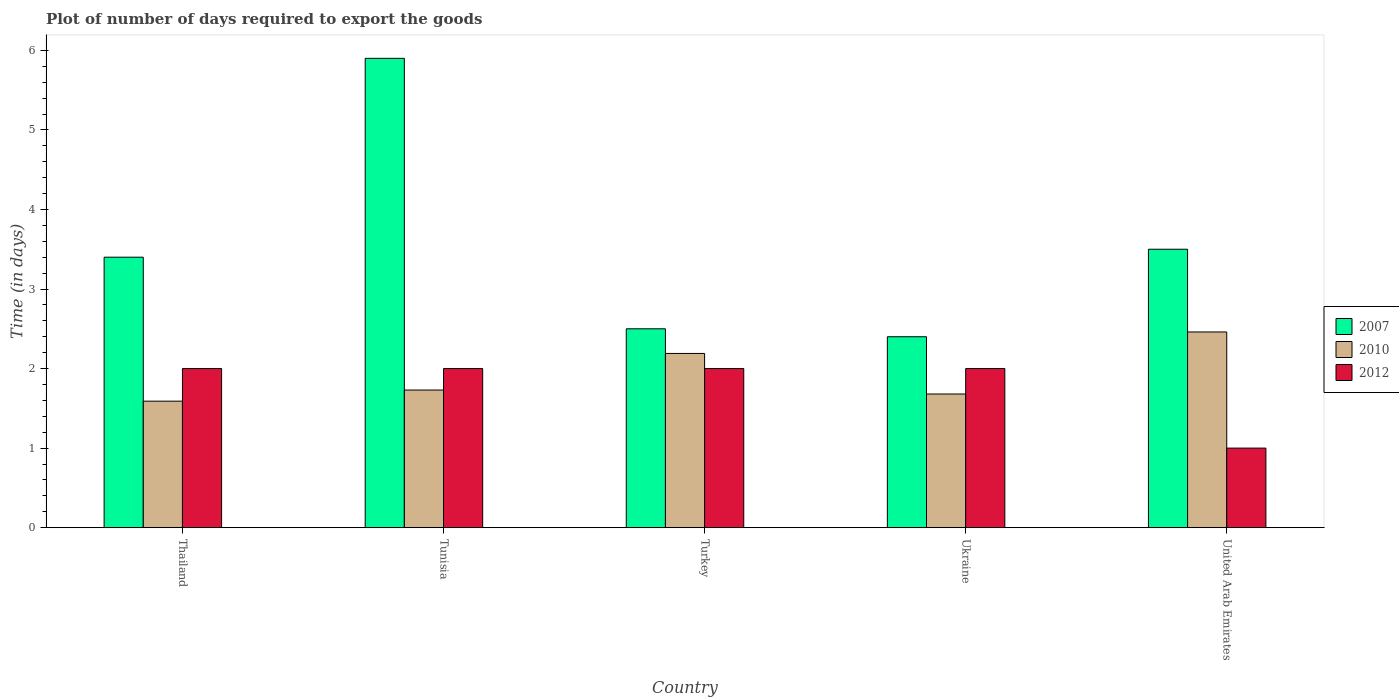What is the label of the 1st group of bars from the left?
Keep it short and to the point. Thailand. In how many cases, is the number of bars for a given country not equal to the number of legend labels?
Your answer should be very brief. 0. What is the time required to export goods in 2007 in Ukraine?
Give a very brief answer. 2.4. Across all countries, what is the maximum time required to export goods in 2012?
Your response must be concise. 2. Across all countries, what is the minimum time required to export goods in 2007?
Keep it short and to the point. 2.4. In which country was the time required to export goods in 2010 maximum?
Offer a terse response. United Arab Emirates. In which country was the time required to export goods in 2007 minimum?
Your answer should be very brief. Ukraine. What is the total time required to export goods in 2010 in the graph?
Make the answer very short. 9.65. What is the difference between the time required to export goods in 2012 in Turkey and that in Ukraine?
Your answer should be very brief. 0. What is the average time required to export goods in 2007 per country?
Make the answer very short. 3.54. What is the difference between the time required to export goods of/in 2012 and time required to export goods of/in 2010 in Ukraine?
Give a very brief answer. 0.32. In how many countries, is the time required to export goods in 2010 greater than 0.8 days?
Your answer should be very brief. 5. What is the ratio of the time required to export goods in 2012 in Tunisia to that in Ukraine?
Offer a terse response. 1. Is the time required to export goods in 2012 in Thailand less than that in Tunisia?
Provide a succinct answer. No. What is the difference between the highest and the second highest time required to export goods in 2007?
Your answer should be very brief. -0.1. What does the 3rd bar from the left in Ukraine represents?
Provide a short and direct response. 2012. What does the 1st bar from the right in Ukraine represents?
Make the answer very short. 2012. Is it the case that in every country, the sum of the time required to export goods in 2007 and time required to export goods in 2010 is greater than the time required to export goods in 2012?
Offer a terse response. Yes. Are all the bars in the graph horizontal?
Ensure brevity in your answer.  No. How many countries are there in the graph?
Keep it short and to the point. 5. Are the values on the major ticks of Y-axis written in scientific E-notation?
Your answer should be very brief. No. Does the graph contain any zero values?
Your response must be concise. No. How many legend labels are there?
Make the answer very short. 3. How are the legend labels stacked?
Give a very brief answer. Vertical. What is the title of the graph?
Keep it short and to the point. Plot of number of days required to export the goods. What is the label or title of the X-axis?
Provide a succinct answer. Country. What is the label or title of the Y-axis?
Provide a short and direct response. Time (in days). What is the Time (in days) in 2010 in Thailand?
Ensure brevity in your answer.  1.59. What is the Time (in days) in 2012 in Thailand?
Provide a succinct answer. 2. What is the Time (in days) in 2007 in Tunisia?
Keep it short and to the point. 5.9. What is the Time (in days) in 2010 in Tunisia?
Provide a short and direct response. 1.73. What is the Time (in days) in 2012 in Tunisia?
Offer a terse response. 2. What is the Time (in days) in 2007 in Turkey?
Your answer should be very brief. 2.5. What is the Time (in days) of 2010 in Turkey?
Your response must be concise. 2.19. What is the Time (in days) of 2012 in Turkey?
Give a very brief answer. 2. What is the Time (in days) in 2007 in Ukraine?
Offer a very short reply. 2.4. What is the Time (in days) in 2010 in Ukraine?
Your answer should be very brief. 1.68. What is the Time (in days) in 2010 in United Arab Emirates?
Give a very brief answer. 2.46. What is the Time (in days) in 2012 in United Arab Emirates?
Your response must be concise. 1. Across all countries, what is the maximum Time (in days) of 2010?
Your response must be concise. 2.46. Across all countries, what is the maximum Time (in days) in 2012?
Your response must be concise. 2. Across all countries, what is the minimum Time (in days) in 2007?
Give a very brief answer. 2.4. Across all countries, what is the minimum Time (in days) in 2010?
Offer a terse response. 1.59. What is the total Time (in days) in 2007 in the graph?
Offer a terse response. 17.7. What is the total Time (in days) in 2010 in the graph?
Make the answer very short. 9.65. What is the total Time (in days) in 2012 in the graph?
Your answer should be very brief. 9. What is the difference between the Time (in days) in 2007 in Thailand and that in Tunisia?
Make the answer very short. -2.5. What is the difference between the Time (in days) of 2010 in Thailand and that in Tunisia?
Ensure brevity in your answer.  -0.14. What is the difference between the Time (in days) in 2007 in Thailand and that in Ukraine?
Keep it short and to the point. 1. What is the difference between the Time (in days) in 2010 in Thailand and that in Ukraine?
Provide a short and direct response. -0.09. What is the difference between the Time (in days) in 2010 in Thailand and that in United Arab Emirates?
Provide a short and direct response. -0.87. What is the difference between the Time (in days) in 2010 in Tunisia and that in Turkey?
Provide a succinct answer. -0.46. What is the difference between the Time (in days) of 2010 in Tunisia and that in United Arab Emirates?
Offer a very short reply. -0.73. What is the difference between the Time (in days) in 2007 in Turkey and that in Ukraine?
Provide a short and direct response. 0.1. What is the difference between the Time (in days) of 2010 in Turkey and that in Ukraine?
Offer a very short reply. 0.51. What is the difference between the Time (in days) in 2012 in Turkey and that in Ukraine?
Make the answer very short. 0. What is the difference between the Time (in days) in 2010 in Turkey and that in United Arab Emirates?
Provide a succinct answer. -0.27. What is the difference between the Time (in days) in 2012 in Turkey and that in United Arab Emirates?
Your answer should be compact. 1. What is the difference between the Time (in days) of 2010 in Ukraine and that in United Arab Emirates?
Provide a short and direct response. -0.78. What is the difference between the Time (in days) of 2012 in Ukraine and that in United Arab Emirates?
Offer a very short reply. 1. What is the difference between the Time (in days) of 2007 in Thailand and the Time (in days) of 2010 in Tunisia?
Your answer should be very brief. 1.67. What is the difference between the Time (in days) of 2007 in Thailand and the Time (in days) of 2012 in Tunisia?
Your response must be concise. 1.4. What is the difference between the Time (in days) of 2010 in Thailand and the Time (in days) of 2012 in Tunisia?
Your response must be concise. -0.41. What is the difference between the Time (in days) of 2007 in Thailand and the Time (in days) of 2010 in Turkey?
Give a very brief answer. 1.21. What is the difference between the Time (in days) of 2010 in Thailand and the Time (in days) of 2012 in Turkey?
Ensure brevity in your answer.  -0.41. What is the difference between the Time (in days) of 2007 in Thailand and the Time (in days) of 2010 in Ukraine?
Ensure brevity in your answer.  1.72. What is the difference between the Time (in days) of 2007 in Thailand and the Time (in days) of 2012 in Ukraine?
Your answer should be very brief. 1.4. What is the difference between the Time (in days) in 2010 in Thailand and the Time (in days) in 2012 in Ukraine?
Your answer should be very brief. -0.41. What is the difference between the Time (in days) in 2007 in Thailand and the Time (in days) in 2010 in United Arab Emirates?
Offer a terse response. 0.94. What is the difference between the Time (in days) in 2010 in Thailand and the Time (in days) in 2012 in United Arab Emirates?
Offer a terse response. 0.59. What is the difference between the Time (in days) in 2007 in Tunisia and the Time (in days) in 2010 in Turkey?
Keep it short and to the point. 3.71. What is the difference between the Time (in days) in 2010 in Tunisia and the Time (in days) in 2012 in Turkey?
Ensure brevity in your answer.  -0.27. What is the difference between the Time (in days) in 2007 in Tunisia and the Time (in days) in 2010 in Ukraine?
Your answer should be compact. 4.22. What is the difference between the Time (in days) of 2010 in Tunisia and the Time (in days) of 2012 in Ukraine?
Offer a very short reply. -0.27. What is the difference between the Time (in days) in 2007 in Tunisia and the Time (in days) in 2010 in United Arab Emirates?
Provide a short and direct response. 3.44. What is the difference between the Time (in days) of 2007 in Tunisia and the Time (in days) of 2012 in United Arab Emirates?
Ensure brevity in your answer.  4.9. What is the difference between the Time (in days) of 2010 in Tunisia and the Time (in days) of 2012 in United Arab Emirates?
Your answer should be very brief. 0.73. What is the difference between the Time (in days) in 2007 in Turkey and the Time (in days) in 2010 in Ukraine?
Provide a succinct answer. 0.82. What is the difference between the Time (in days) in 2010 in Turkey and the Time (in days) in 2012 in Ukraine?
Provide a short and direct response. 0.19. What is the difference between the Time (in days) in 2010 in Turkey and the Time (in days) in 2012 in United Arab Emirates?
Keep it short and to the point. 1.19. What is the difference between the Time (in days) of 2007 in Ukraine and the Time (in days) of 2010 in United Arab Emirates?
Your answer should be compact. -0.06. What is the difference between the Time (in days) in 2010 in Ukraine and the Time (in days) in 2012 in United Arab Emirates?
Give a very brief answer. 0.68. What is the average Time (in days) in 2007 per country?
Your answer should be compact. 3.54. What is the average Time (in days) of 2010 per country?
Your answer should be very brief. 1.93. What is the average Time (in days) of 2012 per country?
Provide a succinct answer. 1.8. What is the difference between the Time (in days) of 2007 and Time (in days) of 2010 in Thailand?
Ensure brevity in your answer.  1.81. What is the difference between the Time (in days) in 2010 and Time (in days) in 2012 in Thailand?
Make the answer very short. -0.41. What is the difference between the Time (in days) in 2007 and Time (in days) in 2010 in Tunisia?
Ensure brevity in your answer.  4.17. What is the difference between the Time (in days) in 2010 and Time (in days) in 2012 in Tunisia?
Offer a very short reply. -0.27. What is the difference between the Time (in days) of 2007 and Time (in days) of 2010 in Turkey?
Offer a terse response. 0.31. What is the difference between the Time (in days) of 2007 and Time (in days) of 2012 in Turkey?
Your answer should be compact. 0.5. What is the difference between the Time (in days) in 2010 and Time (in days) in 2012 in Turkey?
Provide a short and direct response. 0.19. What is the difference between the Time (in days) in 2007 and Time (in days) in 2010 in Ukraine?
Make the answer very short. 0.72. What is the difference between the Time (in days) in 2010 and Time (in days) in 2012 in Ukraine?
Ensure brevity in your answer.  -0.32. What is the difference between the Time (in days) of 2007 and Time (in days) of 2012 in United Arab Emirates?
Your response must be concise. 2.5. What is the difference between the Time (in days) of 2010 and Time (in days) of 2012 in United Arab Emirates?
Your response must be concise. 1.46. What is the ratio of the Time (in days) of 2007 in Thailand to that in Tunisia?
Your response must be concise. 0.58. What is the ratio of the Time (in days) of 2010 in Thailand to that in Tunisia?
Ensure brevity in your answer.  0.92. What is the ratio of the Time (in days) in 2007 in Thailand to that in Turkey?
Give a very brief answer. 1.36. What is the ratio of the Time (in days) of 2010 in Thailand to that in Turkey?
Provide a short and direct response. 0.73. What is the ratio of the Time (in days) of 2012 in Thailand to that in Turkey?
Offer a very short reply. 1. What is the ratio of the Time (in days) in 2007 in Thailand to that in Ukraine?
Provide a succinct answer. 1.42. What is the ratio of the Time (in days) in 2010 in Thailand to that in Ukraine?
Your answer should be very brief. 0.95. What is the ratio of the Time (in days) of 2012 in Thailand to that in Ukraine?
Offer a very short reply. 1. What is the ratio of the Time (in days) of 2007 in Thailand to that in United Arab Emirates?
Provide a short and direct response. 0.97. What is the ratio of the Time (in days) of 2010 in Thailand to that in United Arab Emirates?
Ensure brevity in your answer.  0.65. What is the ratio of the Time (in days) in 2007 in Tunisia to that in Turkey?
Your response must be concise. 2.36. What is the ratio of the Time (in days) in 2010 in Tunisia to that in Turkey?
Provide a succinct answer. 0.79. What is the ratio of the Time (in days) of 2012 in Tunisia to that in Turkey?
Your response must be concise. 1. What is the ratio of the Time (in days) of 2007 in Tunisia to that in Ukraine?
Give a very brief answer. 2.46. What is the ratio of the Time (in days) in 2010 in Tunisia to that in Ukraine?
Make the answer very short. 1.03. What is the ratio of the Time (in days) of 2007 in Tunisia to that in United Arab Emirates?
Your answer should be very brief. 1.69. What is the ratio of the Time (in days) of 2010 in Tunisia to that in United Arab Emirates?
Give a very brief answer. 0.7. What is the ratio of the Time (in days) of 2007 in Turkey to that in Ukraine?
Offer a terse response. 1.04. What is the ratio of the Time (in days) of 2010 in Turkey to that in Ukraine?
Your answer should be very brief. 1.3. What is the ratio of the Time (in days) of 2010 in Turkey to that in United Arab Emirates?
Make the answer very short. 0.89. What is the ratio of the Time (in days) of 2012 in Turkey to that in United Arab Emirates?
Keep it short and to the point. 2. What is the ratio of the Time (in days) in 2007 in Ukraine to that in United Arab Emirates?
Offer a very short reply. 0.69. What is the ratio of the Time (in days) of 2010 in Ukraine to that in United Arab Emirates?
Keep it short and to the point. 0.68. What is the difference between the highest and the second highest Time (in days) in 2007?
Offer a very short reply. 2.4. What is the difference between the highest and the second highest Time (in days) in 2010?
Make the answer very short. 0.27. What is the difference between the highest and the second highest Time (in days) in 2012?
Your response must be concise. 0. What is the difference between the highest and the lowest Time (in days) of 2010?
Make the answer very short. 0.87. What is the difference between the highest and the lowest Time (in days) of 2012?
Provide a succinct answer. 1. 